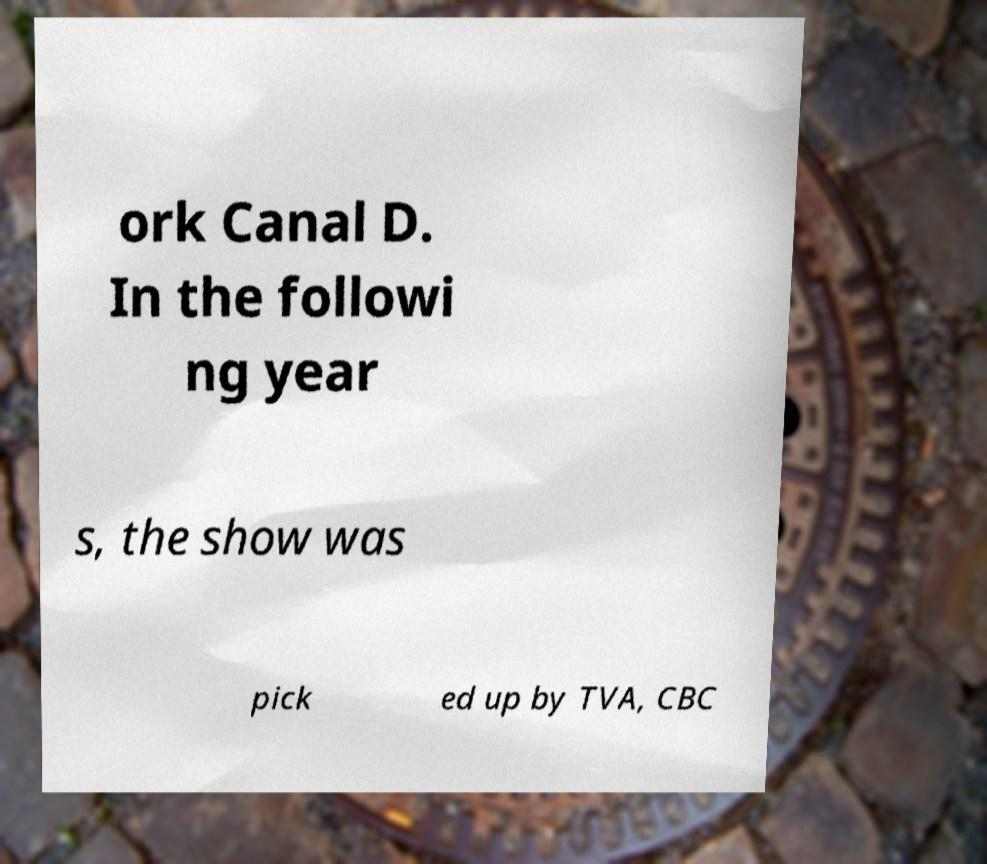Can you accurately transcribe the text from the provided image for me? ork Canal D. In the followi ng year s, the show was pick ed up by TVA, CBC 